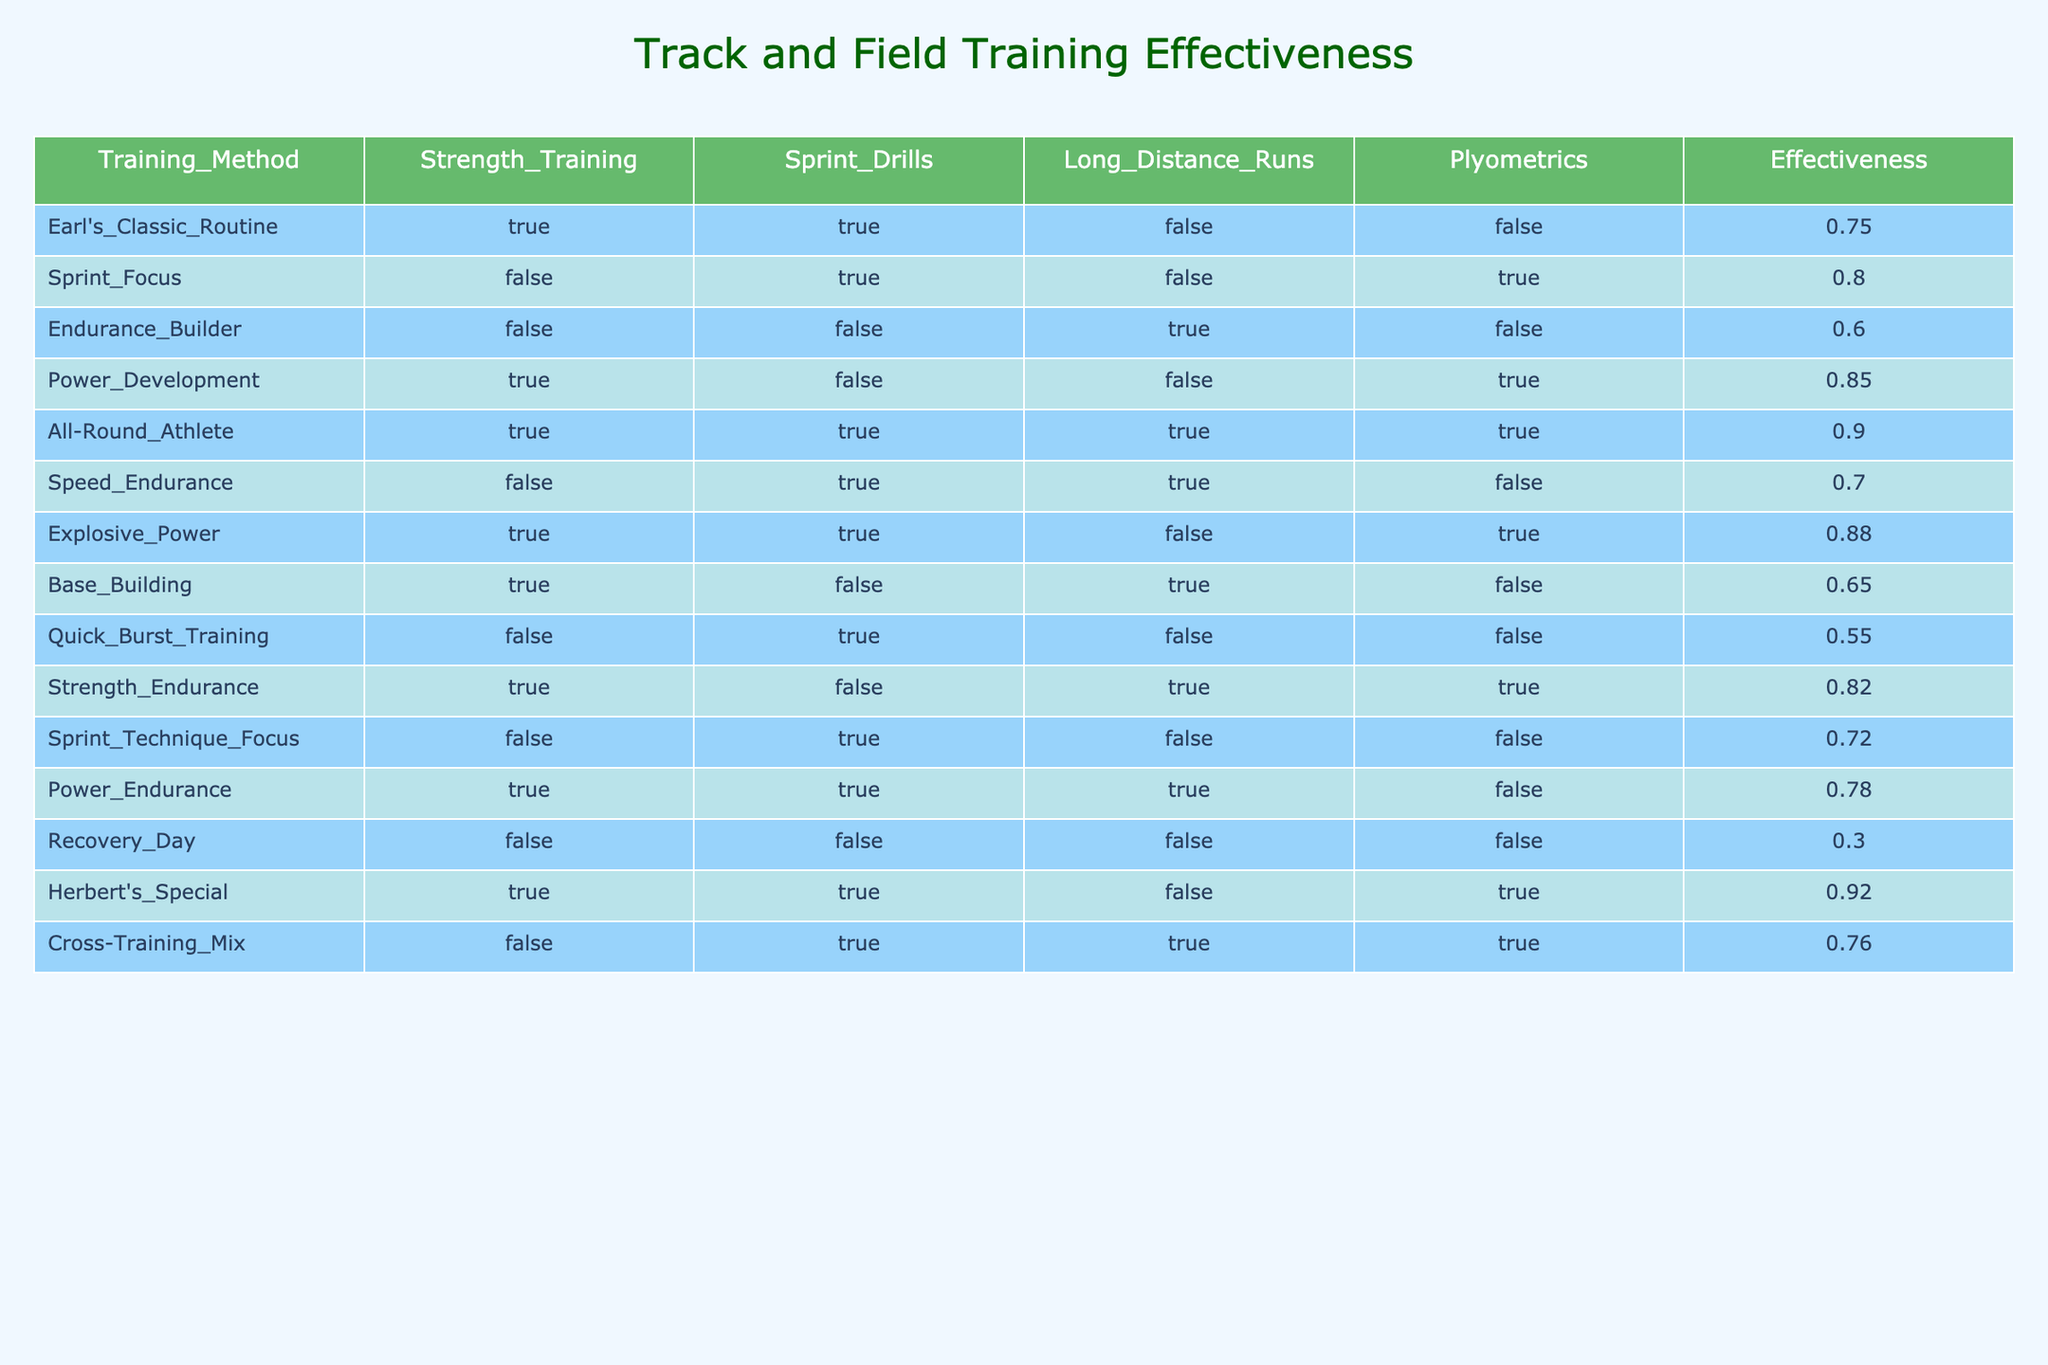What is the effectiveness rating of Earl's Classic Routine? The effectiveness rating for Earl's Classic Routine is given directly in the table under the Effectiveness column. It is listed as 0.75.
Answer: 0.75 Which training method has the highest effectiveness rating? By examining the Effectiveness column, we can see that All-Round Athlete has the highest rating of 0.90. It is explicitly shown in the table.
Answer: All-Round Athlete How many training methods include Plyometrics? We can count the rows where Plyometrics is marked as true. The entries are Sprint Focus, Power Development, Explosive Power, Strength Endurance, Power Endurance, Herbert's Special, and Cross-Training Mix, making a total of 7 training methods.
Answer: 7 Is the Endurance Builder training method effective? By checking the Effectiveness column, we see that Endurance Builder has a rating of 0.60. Since this rating is below 0.50, it indicates lower effectiveness, so we can conclude that it is not effective.
Answer: No Which training regimens combine Sprint Drills and Strength Training? We look for rows where both Sprint Drills and Strength Training are marked as true. Earl's Classic Routine, All-Round Athlete, and Herbert's Special fit this criteria. Thus, there are 3 training regimens that combine them.
Answer: 3 What is the average effectiveness rating of training regimens that focus exclusively on sprinting (Sprint Drills as the only "True")? We identify the regimens that focus exclusively on Sprint Drills, which are Sprint Focus, Quick Burst Training, and Sprint Technique Focus. Their effectiveness ratings are 0.80, 0.55, and 0.72, respectively. Summing these values: 0.80 + 0.55 + 0.72 = 2.07. We then divide by 3 to find the average: 2.07 / 3 = 0.69.
Answer: 0.69 Do any training regimens have an effectiveness score of 0.60 or lower? We check the Effectiveness column for ratings at or below 0.60. The regimens that qualify are Endurance Builder at 0.60, Quick Burst Training at 0.55, and Recovery Day at 0.30. Since there are three regimens, the answer is yes.
Answer: Yes How many training methods are focused on building strength without incorporating sprinting? We look for rows where Strength Training is true and Sprint Drills is false. These methods are Earl’s Classic Routine, Power Development, Base Building, and Strength Endurance. Thus, there are 4 such training methods.
Answer: 4 What is the difference in effectiveness between the Power Development and the All-Round Athlete methods? The effectiveness of Power Development is 0.85, and that of All-Round Athlete is 0.90. We calculate the difference: 0.90 - 0.85 = 0.05. Thus, All-Round Athlete is 0.05 more effective than Power Development.
Answer: 0.05 